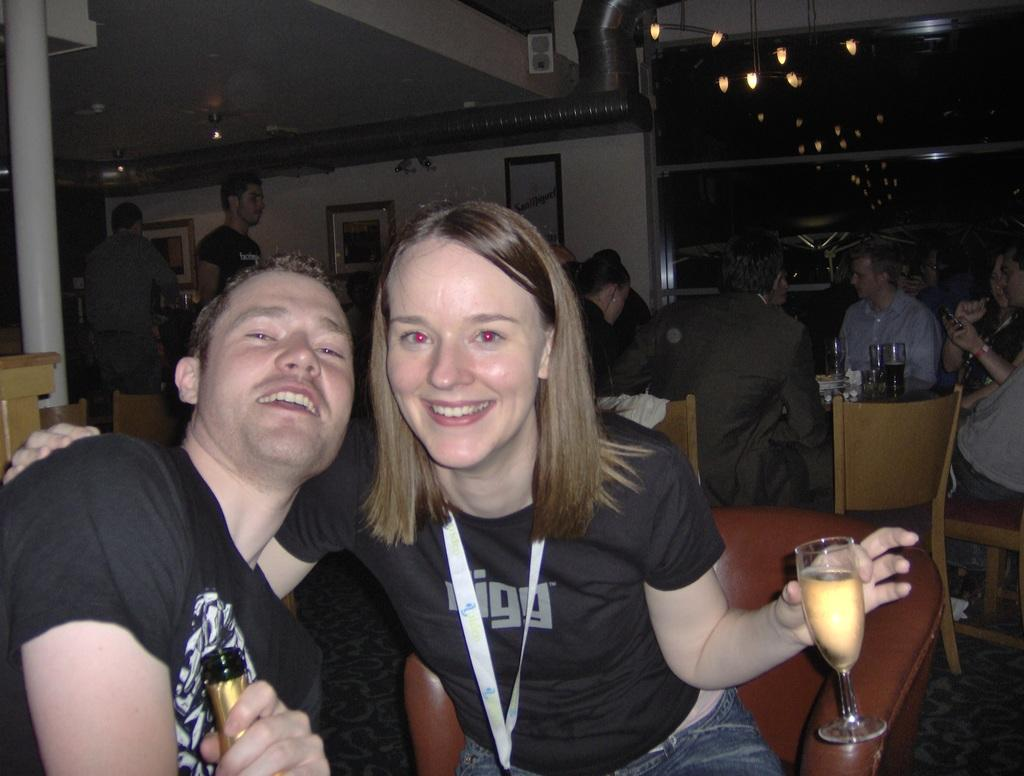<image>
Render a clear and concise summary of the photo. A couple in a restaurant where a girl is wearing a T-Shirt with visible letter of "igg". 